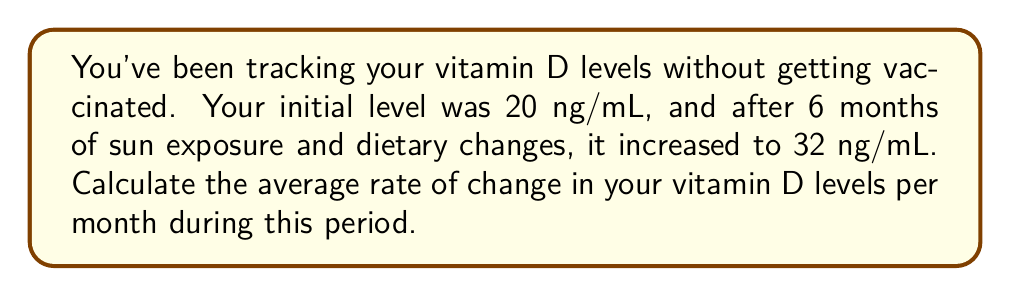Solve this math problem. To calculate the average rate of change, we need to follow these steps:

1. Identify the initial and final values:
   Initial vitamin D level: $20$ ng/mL
   Final vitamin D level: $32$ ng/mL

2. Calculate the total change in vitamin D level:
   $\text{Total change} = \text{Final value} - \text{Initial value}$
   $\text{Total change} = 32 - 20 = 12$ ng/mL

3. Identify the time period:
   Time period: $6$ months

4. Use the formula for average rate of change:
   $$\text{Average rate of change} = \frac{\text{Change in value}}{\text{Change in time}}$$

5. Substitute the values into the formula:
   $$\text{Average rate of change} = \frac{12 \text{ ng/mL}}{6 \text{ months}}$$

6. Simplify:
   $$\text{Average rate of change} = 2 \text{ ng/mL per month}$$
Answer: $2$ ng/mL per month 